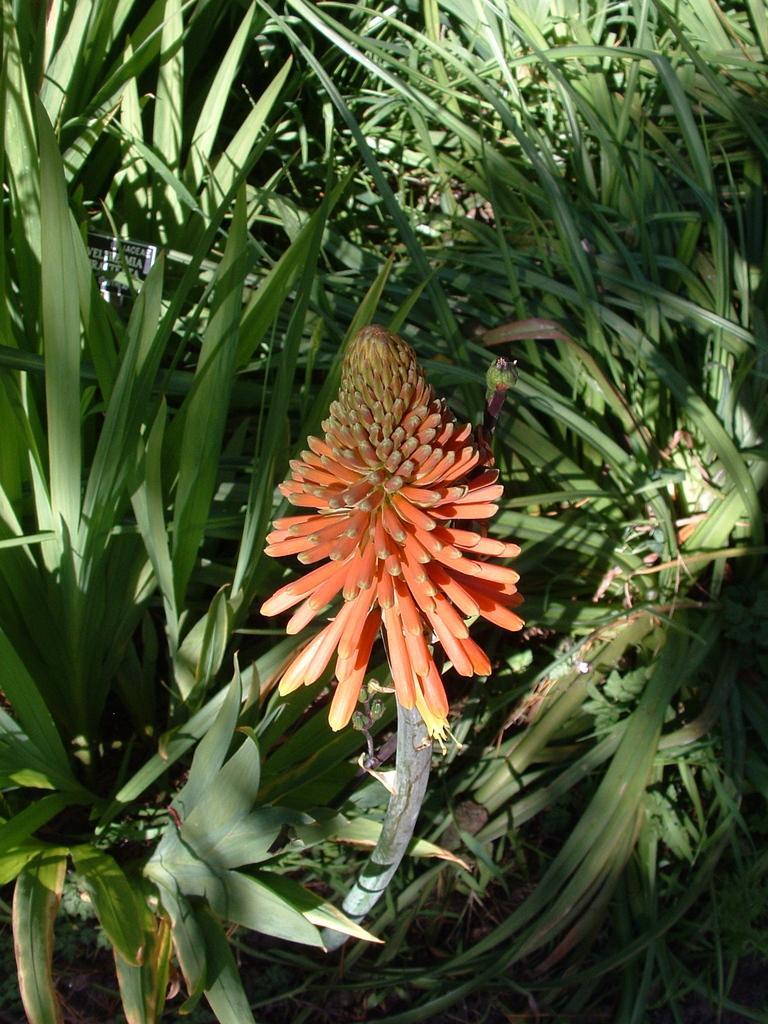In one or two sentences, can you explain what this image depicts? In the foreground of this picture, there is an orange flower to the plants. In the background, we can see the plants. 